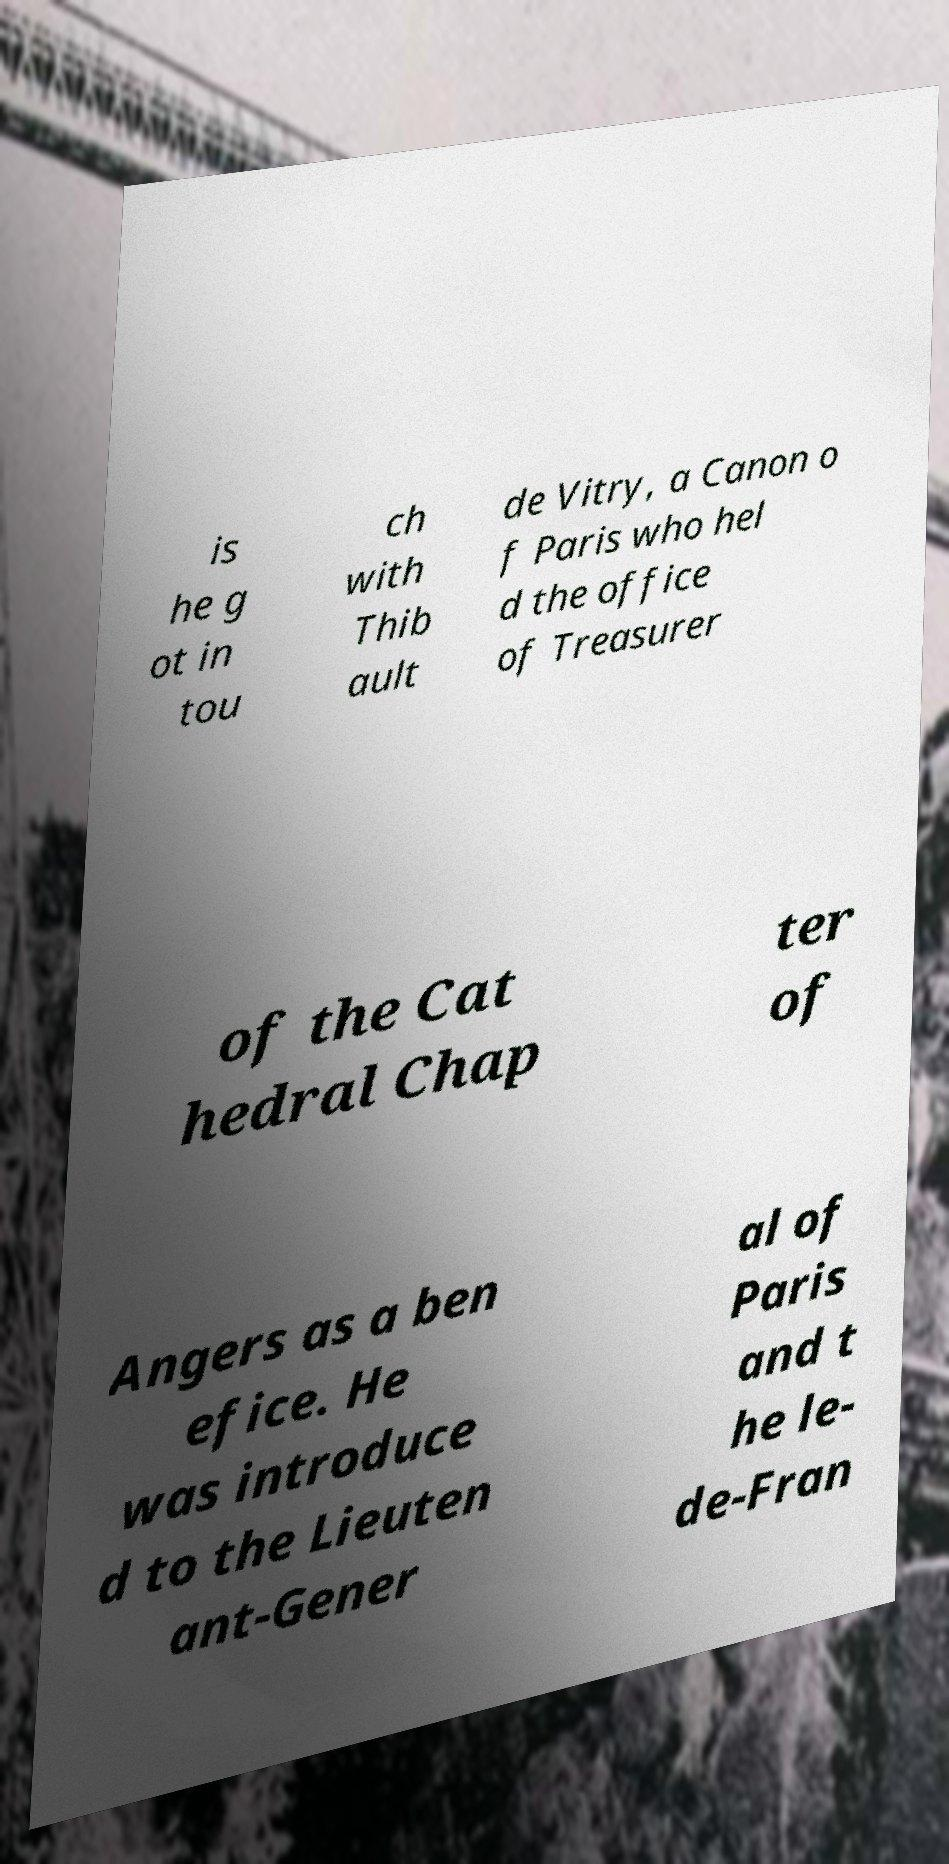Could you assist in decoding the text presented in this image and type it out clearly? is he g ot in tou ch with Thib ault de Vitry, a Canon o f Paris who hel d the office of Treasurer of the Cat hedral Chap ter of Angers as a ben efice. He was introduce d to the Lieuten ant-Gener al of Paris and t he le- de-Fran 